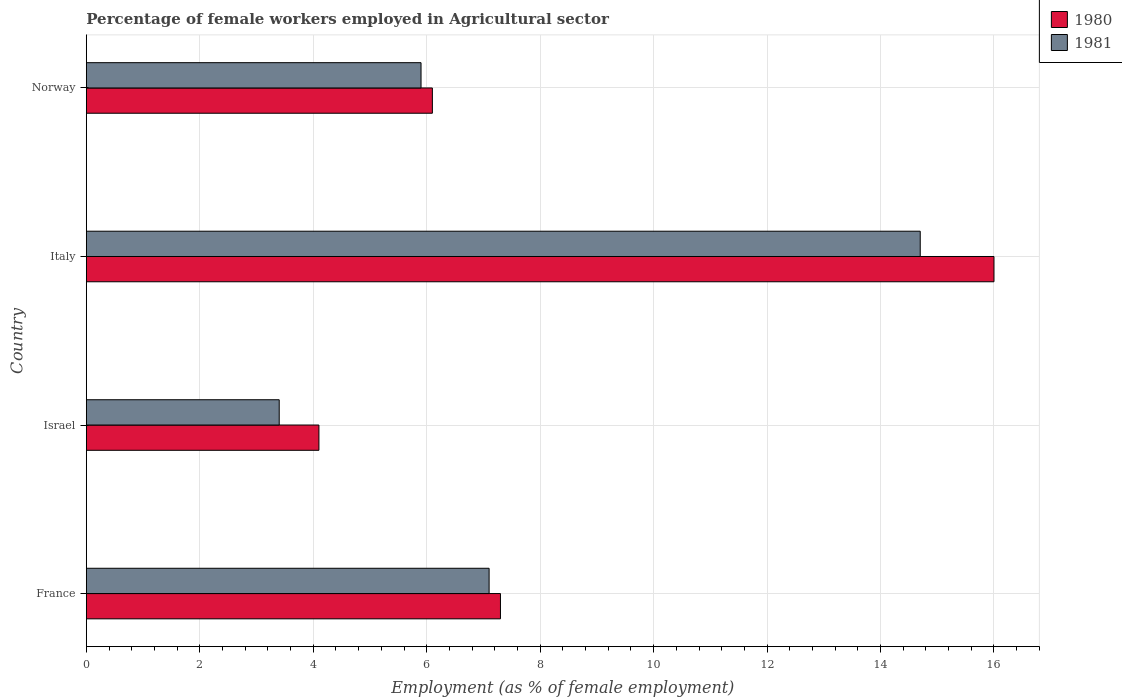How many different coloured bars are there?
Your response must be concise. 2. Are the number of bars per tick equal to the number of legend labels?
Your answer should be compact. Yes. How many bars are there on the 2nd tick from the top?
Keep it short and to the point. 2. What is the label of the 4th group of bars from the top?
Offer a terse response. France. In how many cases, is the number of bars for a given country not equal to the number of legend labels?
Ensure brevity in your answer.  0. What is the percentage of females employed in Agricultural sector in 1981 in Israel?
Provide a succinct answer. 3.4. Across all countries, what is the maximum percentage of females employed in Agricultural sector in 1980?
Your answer should be compact. 16. Across all countries, what is the minimum percentage of females employed in Agricultural sector in 1981?
Keep it short and to the point. 3.4. In which country was the percentage of females employed in Agricultural sector in 1980 minimum?
Offer a very short reply. Israel. What is the total percentage of females employed in Agricultural sector in 1980 in the graph?
Ensure brevity in your answer.  33.5. What is the difference between the percentage of females employed in Agricultural sector in 1981 in France and that in Norway?
Give a very brief answer. 1.2. What is the difference between the percentage of females employed in Agricultural sector in 1981 in Italy and the percentage of females employed in Agricultural sector in 1980 in Norway?
Ensure brevity in your answer.  8.6. What is the average percentage of females employed in Agricultural sector in 1980 per country?
Provide a succinct answer. 8.38. What is the difference between the percentage of females employed in Agricultural sector in 1980 and percentage of females employed in Agricultural sector in 1981 in Italy?
Keep it short and to the point. 1.3. What is the ratio of the percentage of females employed in Agricultural sector in 1980 in Italy to that in Norway?
Provide a short and direct response. 2.62. Is the percentage of females employed in Agricultural sector in 1981 in Italy less than that in Norway?
Offer a very short reply. No. What is the difference between the highest and the second highest percentage of females employed in Agricultural sector in 1981?
Offer a very short reply. 7.6. What is the difference between the highest and the lowest percentage of females employed in Agricultural sector in 1980?
Ensure brevity in your answer.  11.9. What does the 2nd bar from the top in Norway represents?
Ensure brevity in your answer.  1980. How many bars are there?
Your answer should be compact. 8. How many countries are there in the graph?
Keep it short and to the point. 4. What is the difference between two consecutive major ticks on the X-axis?
Make the answer very short. 2. Does the graph contain any zero values?
Your answer should be compact. No. Does the graph contain grids?
Your response must be concise. Yes. How many legend labels are there?
Your response must be concise. 2. How are the legend labels stacked?
Your answer should be compact. Vertical. What is the title of the graph?
Give a very brief answer. Percentage of female workers employed in Agricultural sector. Does "1966" appear as one of the legend labels in the graph?
Make the answer very short. No. What is the label or title of the X-axis?
Make the answer very short. Employment (as % of female employment). What is the Employment (as % of female employment) in 1980 in France?
Give a very brief answer. 7.3. What is the Employment (as % of female employment) of 1981 in France?
Make the answer very short. 7.1. What is the Employment (as % of female employment) in 1980 in Israel?
Your answer should be compact. 4.1. What is the Employment (as % of female employment) in 1981 in Israel?
Your response must be concise. 3.4. What is the Employment (as % of female employment) in 1980 in Italy?
Keep it short and to the point. 16. What is the Employment (as % of female employment) of 1981 in Italy?
Provide a succinct answer. 14.7. What is the Employment (as % of female employment) in 1980 in Norway?
Keep it short and to the point. 6.1. What is the Employment (as % of female employment) of 1981 in Norway?
Offer a terse response. 5.9. Across all countries, what is the maximum Employment (as % of female employment) of 1980?
Your response must be concise. 16. Across all countries, what is the maximum Employment (as % of female employment) in 1981?
Your response must be concise. 14.7. Across all countries, what is the minimum Employment (as % of female employment) in 1980?
Offer a very short reply. 4.1. Across all countries, what is the minimum Employment (as % of female employment) of 1981?
Your answer should be very brief. 3.4. What is the total Employment (as % of female employment) of 1980 in the graph?
Give a very brief answer. 33.5. What is the total Employment (as % of female employment) in 1981 in the graph?
Offer a terse response. 31.1. What is the difference between the Employment (as % of female employment) of 1980 in France and that in Israel?
Give a very brief answer. 3.2. What is the difference between the Employment (as % of female employment) in 1981 in France and that in Israel?
Ensure brevity in your answer.  3.7. What is the difference between the Employment (as % of female employment) in 1981 in France and that in Italy?
Make the answer very short. -7.6. What is the difference between the Employment (as % of female employment) of 1980 in Israel and that in Italy?
Make the answer very short. -11.9. What is the difference between the Employment (as % of female employment) of 1980 in Israel and that in Norway?
Offer a terse response. -2. What is the difference between the Employment (as % of female employment) in 1981 in Israel and that in Norway?
Your answer should be compact. -2.5. What is the difference between the Employment (as % of female employment) of 1980 in France and the Employment (as % of female employment) of 1981 in Israel?
Offer a very short reply. 3.9. What is the difference between the Employment (as % of female employment) in 1980 in France and the Employment (as % of female employment) in 1981 in Italy?
Provide a succinct answer. -7.4. What is the difference between the Employment (as % of female employment) in 1980 in Israel and the Employment (as % of female employment) in 1981 in Norway?
Offer a terse response. -1.8. What is the difference between the Employment (as % of female employment) of 1980 in Italy and the Employment (as % of female employment) of 1981 in Norway?
Keep it short and to the point. 10.1. What is the average Employment (as % of female employment) in 1980 per country?
Give a very brief answer. 8.38. What is the average Employment (as % of female employment) of 1981 per country?
Make the answer very short. 7.78. What is the difference between the Employment (as % of female employment) in 1980 and Employment (as % of female employment) in 1981 in France?
Offer a terse response. 0.2. What is the difference between the Employment (as % of female employment) in 1980 and Employment (as % of female employment) in 1981 in Italy?
Offer a terse response. 1.3. What is the difference between the Employment (as % of female employment) of 1980 and Employment (as % of female employment) of 1981 in Norway?
Provide a succinct answer. 0.2. What is the ratio of the Employment (as % of female employment) of 1980 in France to that in Israel?
Provide a succinct answer. 1.78. What is the ratio of the Employment (as % of female employment) of 1981 in France to that in Israel?
Provide a short and direct response. 2.09. What is the ratio of the Employment (as % of female employment) of 1980 in France to that in Italy?
Give a very brief answer. 0.46. What is the ratio of the Employment (as % of female employment) in 1981 in France to that in Italy?
Provide a short and direct response. 0.48. What is the ratio of the Employment (as % of female employment) of 1980 in France to that in Norway?
Offer a terse response. 1.2. What is the ratio of the Employment (as % of female employment) in 1981 in France to that in Norway?
Provide a short and direct response. 1.2. What is the ratio of the Employment (as % of female employment) in 1980 in Israel to that in Italy?
Keep it short and to the point. 0.26. What is the ratio of the Employment (as % of female employment) of 1981 in Israel to that in Italy?
Your answer should be compact. 0.23. What is the ratio of the Employment (as % of female employment) of 1980 in Israel to that in Norway?
Your answer should be compact. 0.67. What is the ratio of the Employment (as % of female employment) of 1981 in Israel to that in Norway?
Offer a terse response. 0.58. What is the ratio of the Employment (as % of female employment) in 1980 in Italy to that in Norway?
Ensure brevity in your answer.  2.62. What is the ratio of the Employment (as % of female employment) in 1981 in Italy to that in Norway?
Provide a succinct answer. 2.49. What is the difference between the highest and the second highest Employment (as % of female employment) in 1981?
Provide a succinct answer. 7.6. What is the difference between the highest and the lowest Employment (as % of female employment) in 1981?
Your answer should be very brief. 11.3. 